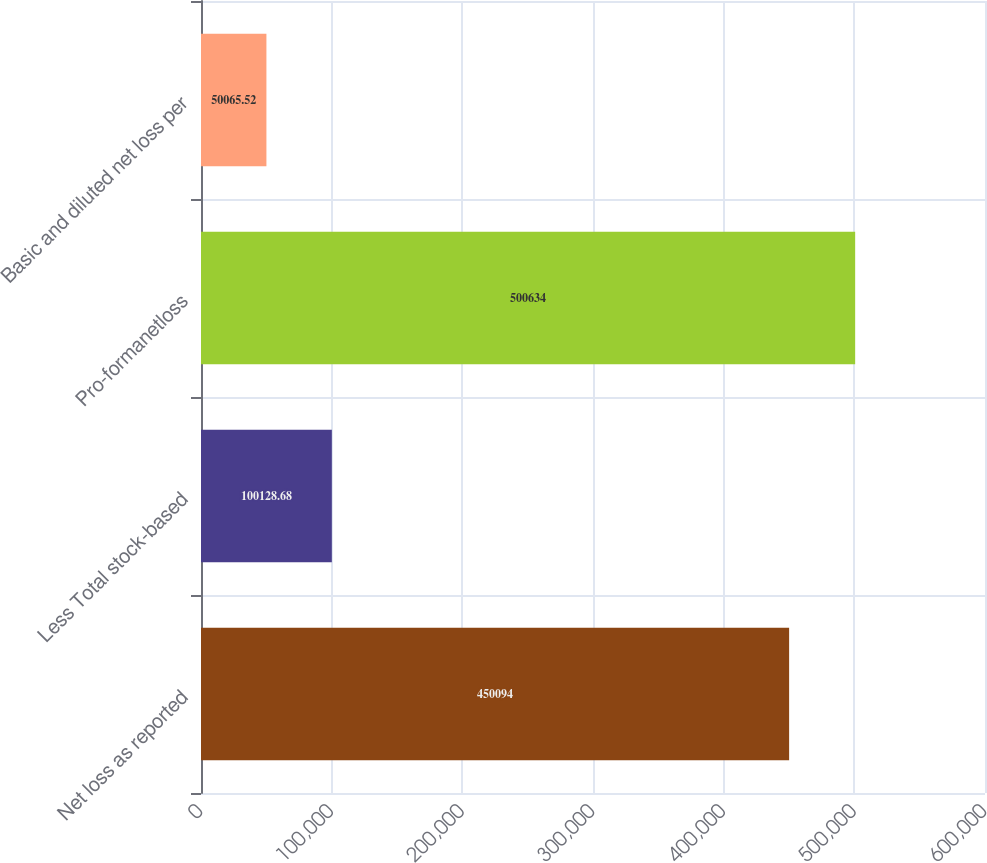<chart> <loc_0><loc_0><loc_500><loc_500><bar_chart><fcel>Net loss as reported<fcel>Less Total stock-based<fcel>Pro-formanetloss<fcel>Basic and diluted net loss per<nl><fcel>450094<fcel>100129<fcel>500634<fcel>50065.5<nl></chart> 